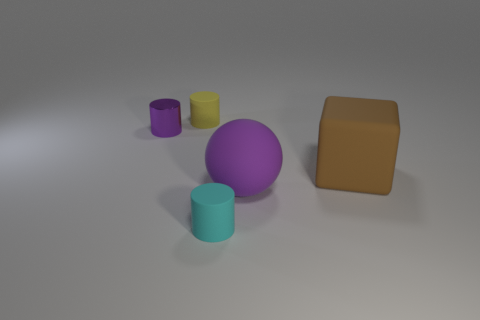How many objects are brown rubber cubes that are behind the small cyan cylinder or yellow metal things?
Keep it short and to the point. 1. The metallic object that is the same color as the large sphere is what size?
Offer a terse response. Small. Does the cylinder that is in front of the tiny purple shiny cylinder have the same color as the cylinder that is left of the yellow thing?
Your answer should be compact. No. The yellow cylinder has what size?
Ensure brevity in your answer.  Small. What number of tiny things are yellow cylinders or purple objects?
Your answer should be compact. 2. What color is the other object that is the same size as the purple matte thing?
Ensure brevity in your answer.  Brown. How many other objects are the same shape as the cyan object?
Give a very brief answer. 2. Is there a big purple sphere made of the same material as the brown cube?
Make the answer very short. Yes. Do the purple thing that is to the left of the large purple object and the purple thing right of the cyan matte cylinder have the same material?
Make the answer very short. No. What number of brown rubber things are there?
Your answer should be compact. 1. 